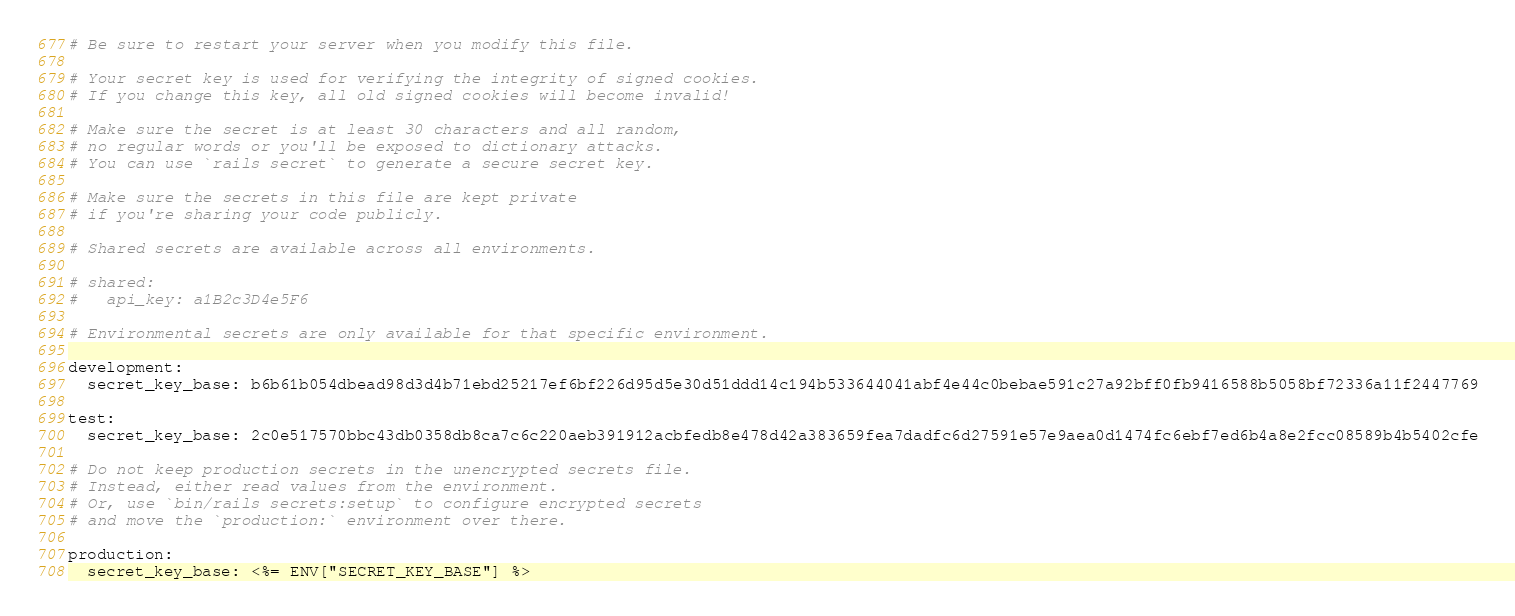Convert code to text. <code><loc_0><loc_0><loc_500><loc_500><_YAML_># Be sure to restart your server when you modify this file.

# Your secret key is used for verifying the integrity of signed cookies.
# If you change this key, all old signed cookies will become invalid!

# Make sure the secret is at least 30 characters and all random,
# no regular words or you'll be exposed to dictionary attacks.
# You can use `rails secret` to generate a secure secret key.

# Make sure the secrets in this file are kept private
# if you're sharing your code publicly.

# Shared secrets are available across all environments.

# shared:
#   api_key: a1B2c3D4e5F6

# Environmental secrets are only available for that specific environment.

development:
  secret_key_base: b6b61b054dbead98d3d4b71ebd25217ef6bf226d95d5e30d51ddd14c194b533644041abf4e44c0bebae591c27a92bff0fb9416588b5058bf72336a11f2447769

test:
  secret_key_base: 2c0e517570bbc43db0358db8ca7c6c220aeb391912acbfedb8e478d42a383659fea7dadfc6d27591e57e9aea0d1474fc6ebf7ed6b4a8e2fcc08589b4b5402cfe

# Do not keep production secrets in the unencrypted secrets file.
# Instead, either read values from the environment.
# Or, use `bin/rails secrets:setup` to configure encrypted secrets
# and move the `production:` environment over there.

production:
  secret_key_base: <%= ENV["SECRET_KEY_BASE"] %>
</code> 